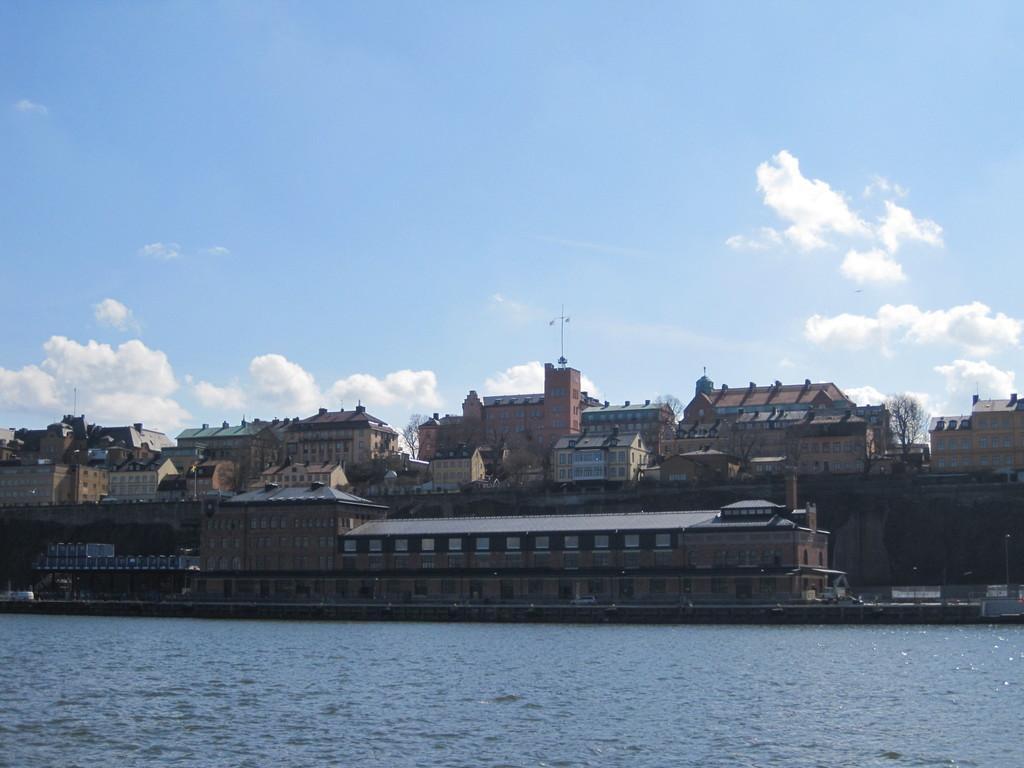Could you give a brief overview of what you see in this image? In this picture I can see there is a river and in the backdrop there are few buildings and trees and the buildings have windows and the sky is clear. 